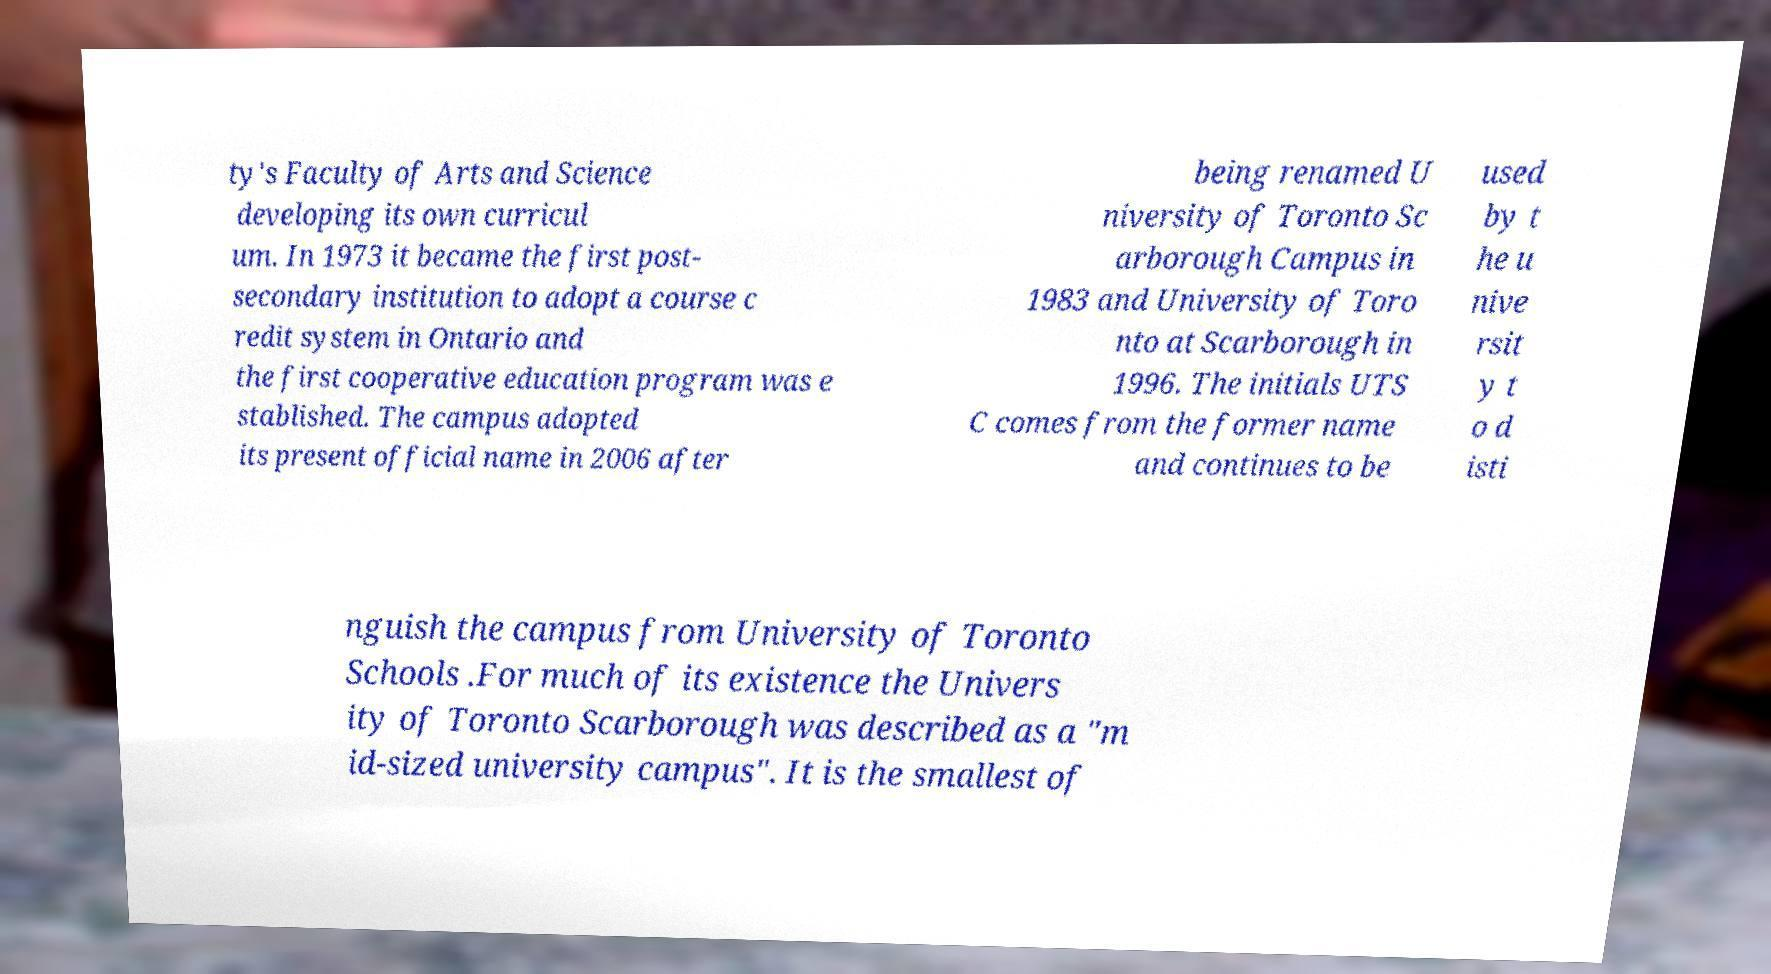Could you assist in decoding the text presented in this image and type it out clearly? ty's Faculty of Arts and Science developing its own curricul um. In 1973 it became the first post- secondary institution to adopt a course c redit system in Ontario and the first cooperative education program was e stablished. The campus adopted its present official name in 2006 after being renamed U niversity of Toronto Sc arborough Campus in 1983 and University of Toro nto at Scarborough in 1996. The initials UTS C comes from the former name and continues to be used by t he u nive rsit y t o d isti nguish the campus from University of Toronto Schools .For much of its existence the Univers ity of Toronto Scarborough was described as a "m id-sized university campus". It is the smallest of 